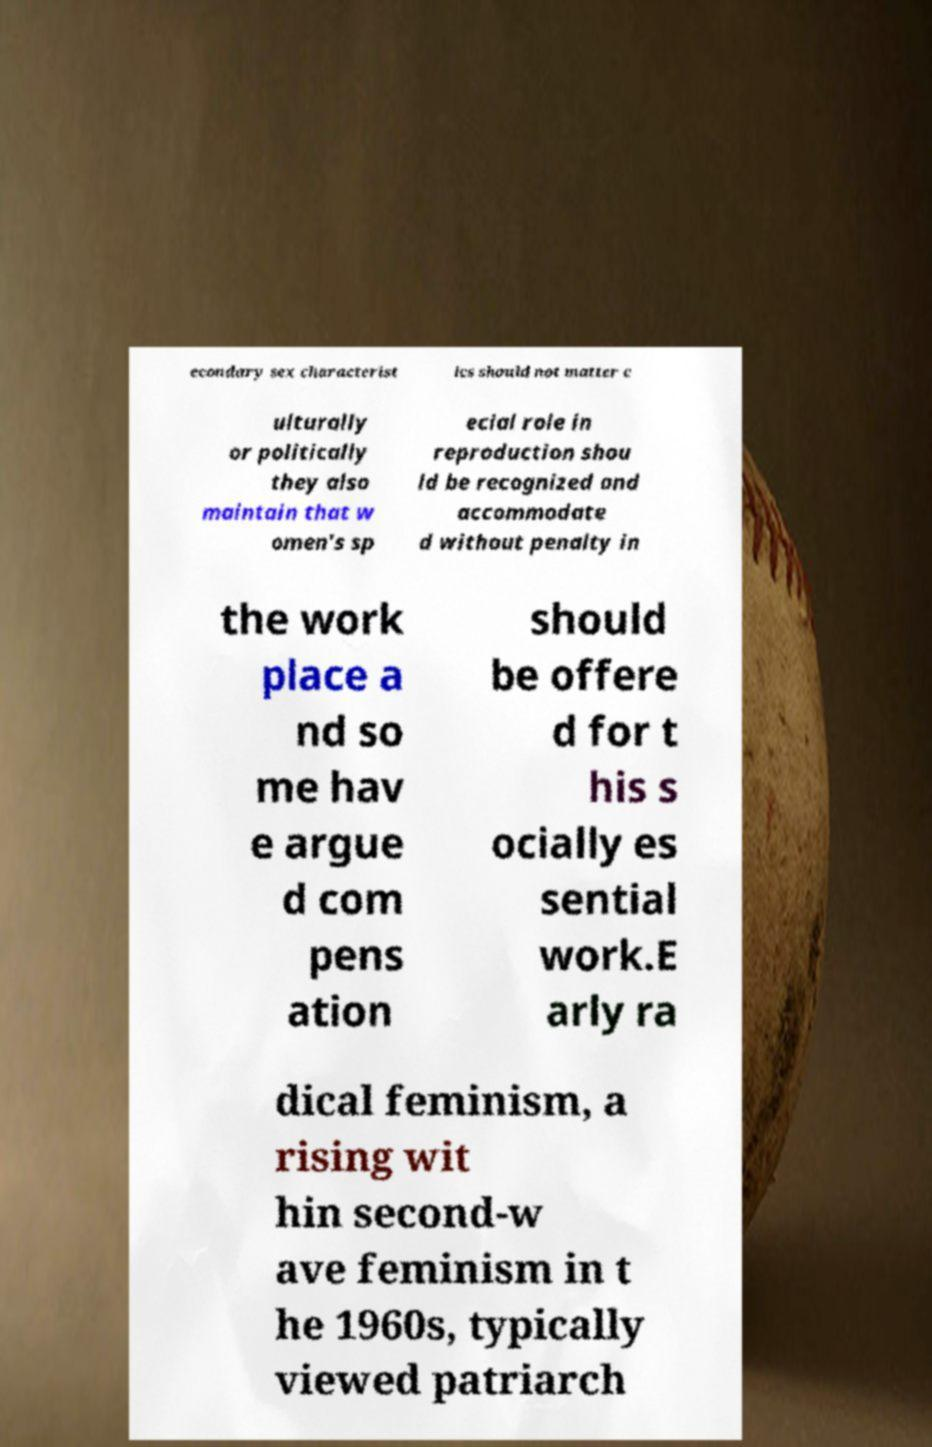Can you accurately transcribe the text from the provided image for me? econdary sex characterist ics should not matter c ulturally or politically they also maintain that w omen's sp ecial role in reproduction shou ld be recognized and accommodate d without penalty in the work place a nd so me hav e argue d com pens ation should be offere d for t his s ocially es sential work.E arly ra dical feminism, a rising wit hin second-w ave feminism in t he 1960s, typically viewed patriarch 